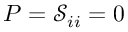Convert formula to latex. <formula><loc_0><loc_0><loc_500><loc_500>P = \mathcal { S } _ { i i } = 0</formula> 